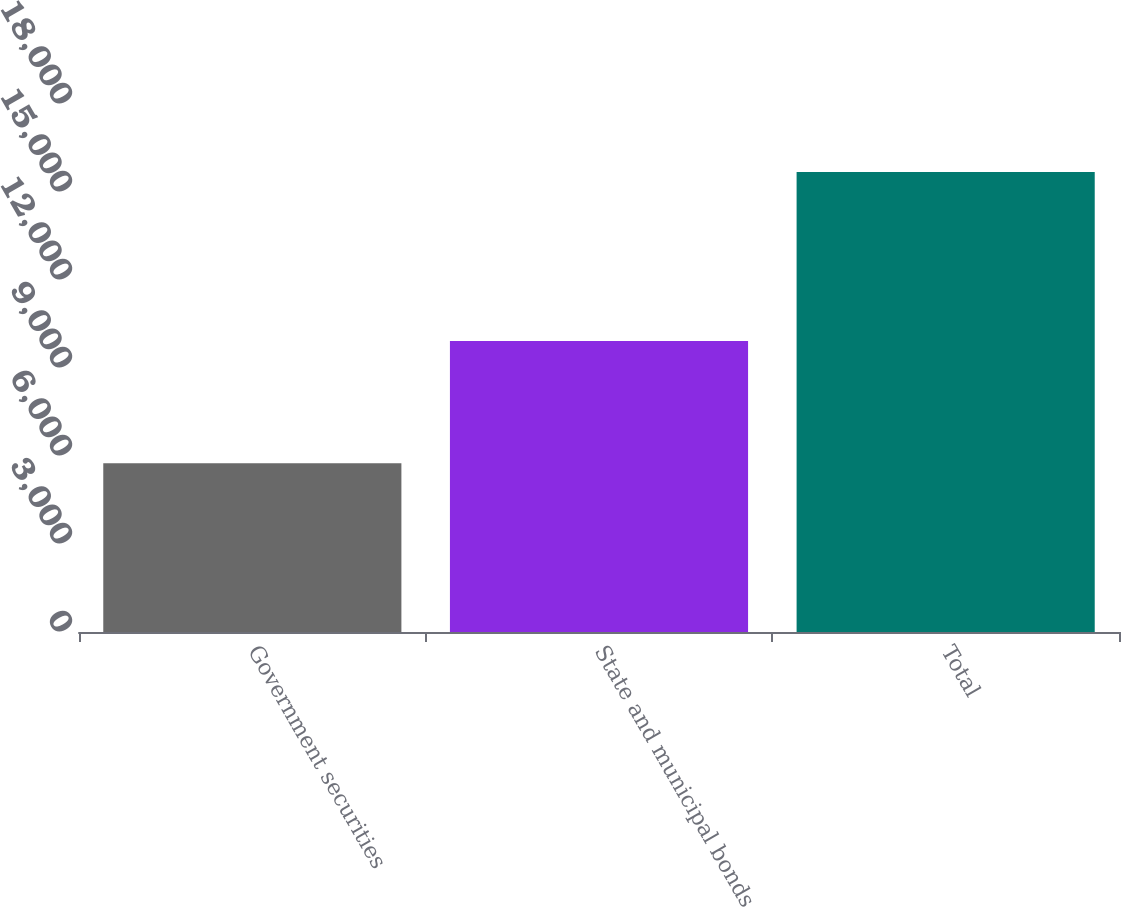Convert chart to OTSL. <chart><loc_0><loc_0><loc_500><loc_500><bar_chart><fcel>Government securities<fcel>State and municipal bonds<fcel>Total<nl><fcel>5755<fcel>9923<fcel>15678<nl></chart> 